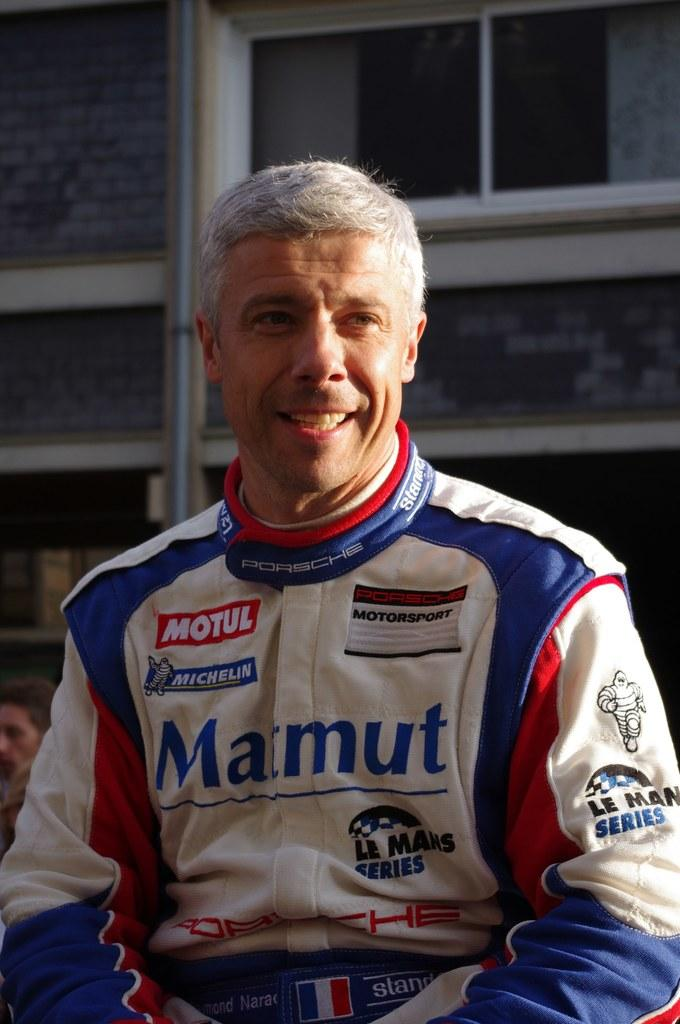<image>
Present a compact description of the photo's key features. a person with the word marmut on his outfit 